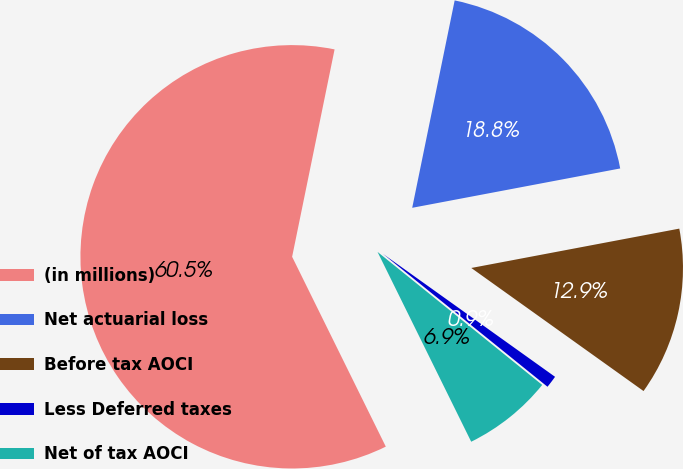Convert chart. <chart><loc_0><loc_0><loc_500><loc_500><pie_chart><fcel>(in millions)<fcel>Net actuarial loss<fcel>Before tax AOCI<fcel>Less Deferred taxes<fcel>Net of tax AOCI<nl><fcel>60.51%<fcel>18.81%<fcel>12.85%<fcel>0.94%<fcel>6.89%<nl></chart> 